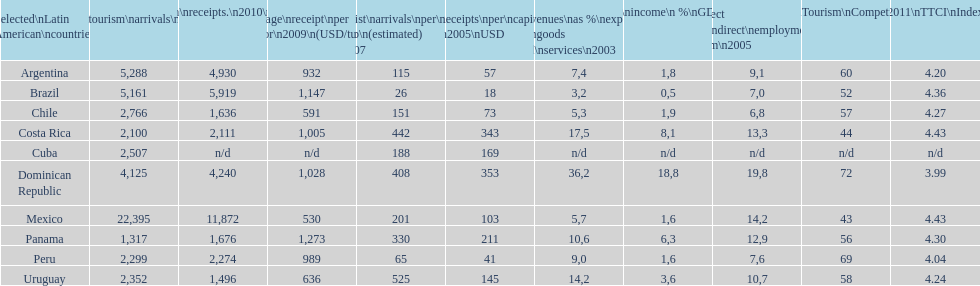What is the ending country showcased on this graph? Uruguay. 